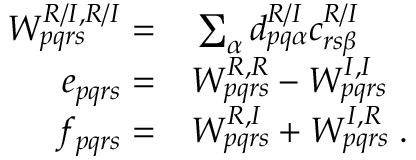Convert formula to latex. <formula><loc_0><loc_0><loc_500><loc_500>\begin{array} { r l } { W _ { p q r s } ^ { R / I , R / I } = } & \sum _ { \alpha } d _ { p q \alpha } ^ { R / I } c _ { r s \beta } ^ { R / I } } \\ { e _ { p q r s } = } & W _ { p q r s } ^ { R , R } - W _ { p q r s } ^ { I , I } } \\ { f _ { p q r s } = } & W _ { p q r s } ^ { R , I } + W _ { p q r s } ^ { I , R } \, . } \end{array}</formula> 